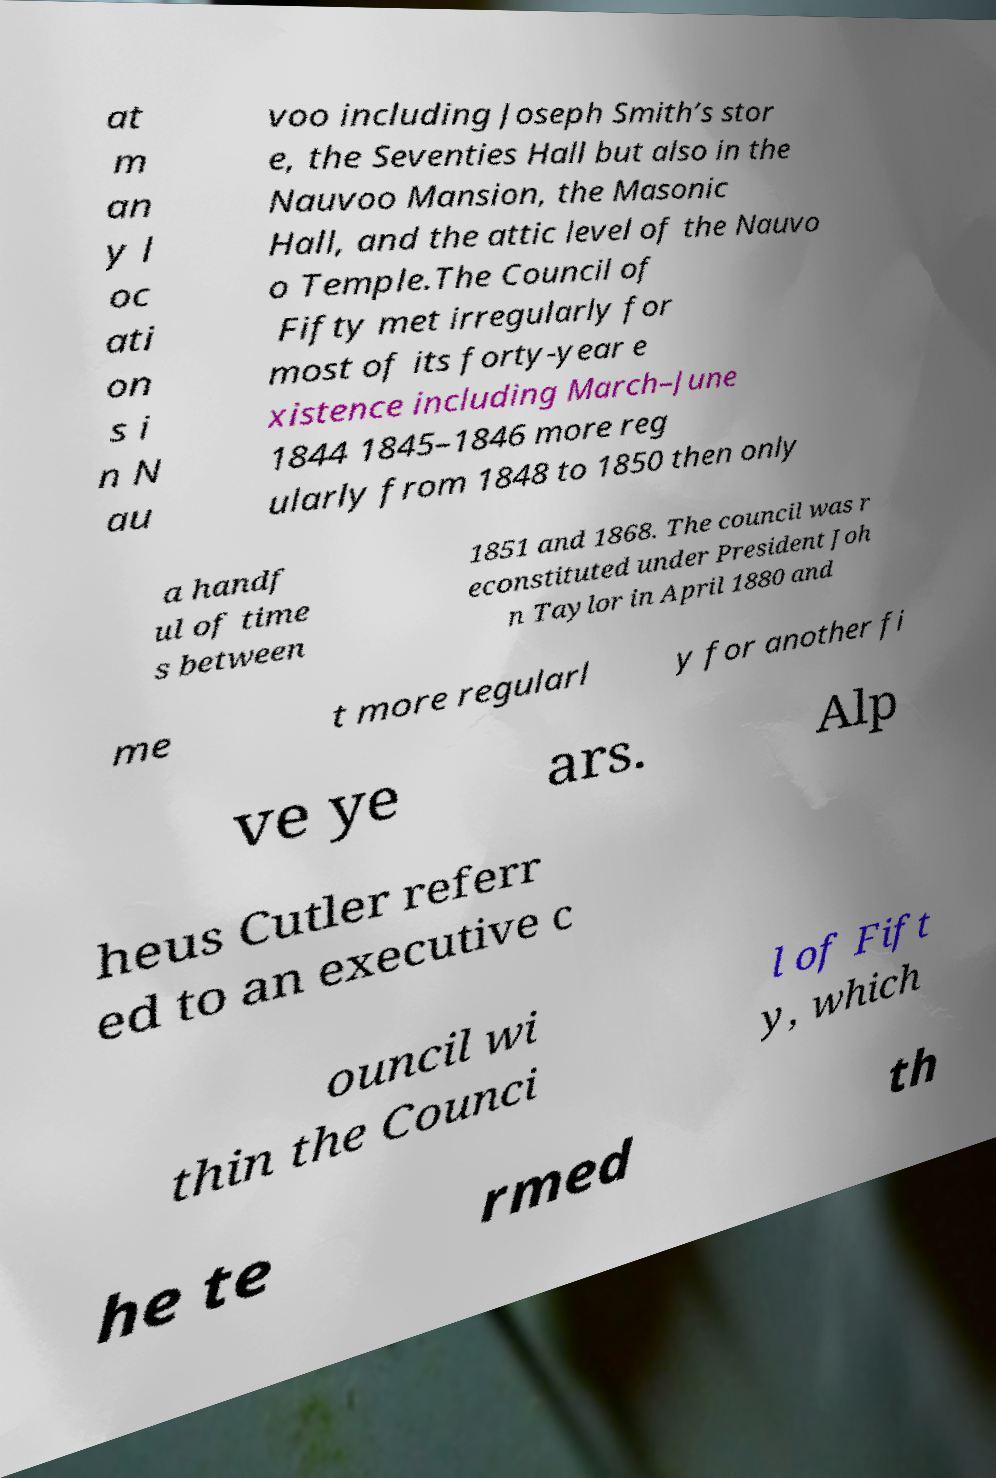Please read and relay the text visible in this image. What does it say? at m an y l oc ati on s i n N au voo including Joseph Smith’s stor e, the Seventies Hall but also in the Nauvoo Mansion, the Masonic Hall, and the attic level of the Nauvo o Temple.The Council of Fifty met irregularly for most of its forty-year e xistence including March–June 1844 1845–1846 more reg ularly from 1848 to 1850 then only a handf ul of time s between 1851 and 1868. The council was r econstituted under President Joh n Taylor in April 1880 and me t more regularl y for another fi ve ye ars. Alp heus Cutler referr ed to an executive c ouncil wi thin the Counci l of Fift y, which he te rmed th 